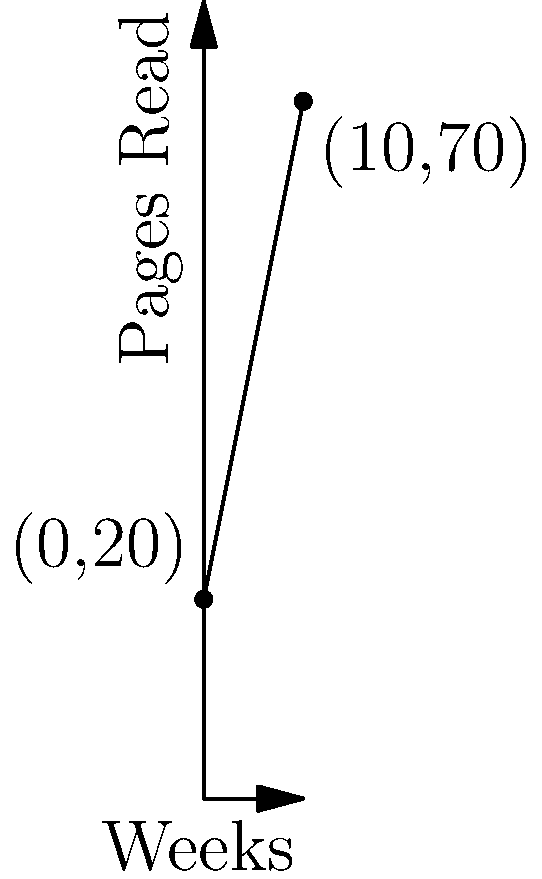As a parent monitoring your child's reading progress, you've plotted their weekly reading data on a graph. The line starts at (0,20) and ends at (10,70), where the x-axis represents weeks and the y-axis represents pages read. Calculate the slope of this line to determine your child's average weekly improvement in reading speed. What does this slope represent in the context of your child's reading progress? To calculate the slope of the line, we'll use the slope formula:

$$ \text{Slope} = \frac{\text{Change in y}}{\text{Change in x}} = \frac{y_2 - y_1}{x_2 - x_1} $$

Given points: (0,20) and (10,70)

Step 1: Identify the coordinates
$(x_1, y_1) = (0, 20)$
$(x_2, y_2) = (10, 70)$

Step 2: Calculate the change in y (vertical change)
$\text{Change in y} = y_2 - y_1 = 70 - 20 = 50$

Step 3: Calculate the change in x (horizontal change)
$\text{Change in x} = x_2 - x_1 = 10 - 0 = 10$

Step 4: Apply the slope formula
$$ \text{Slope} = \frac{50}{10} = 5 $$

Interpretation: The slope of 5 represents the average increase in pages read per week. This means that, on average, your child is reading 5 more pages each week than the previous week. This steady improvement demonstrates consistent progress in their reading speed and possibly comprehension over time.
Answer: 5 pages per week 